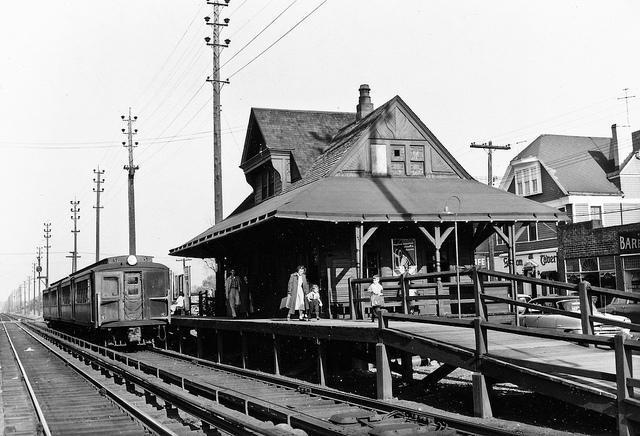How many people in the photo?
Give a very brief answer. 5. 